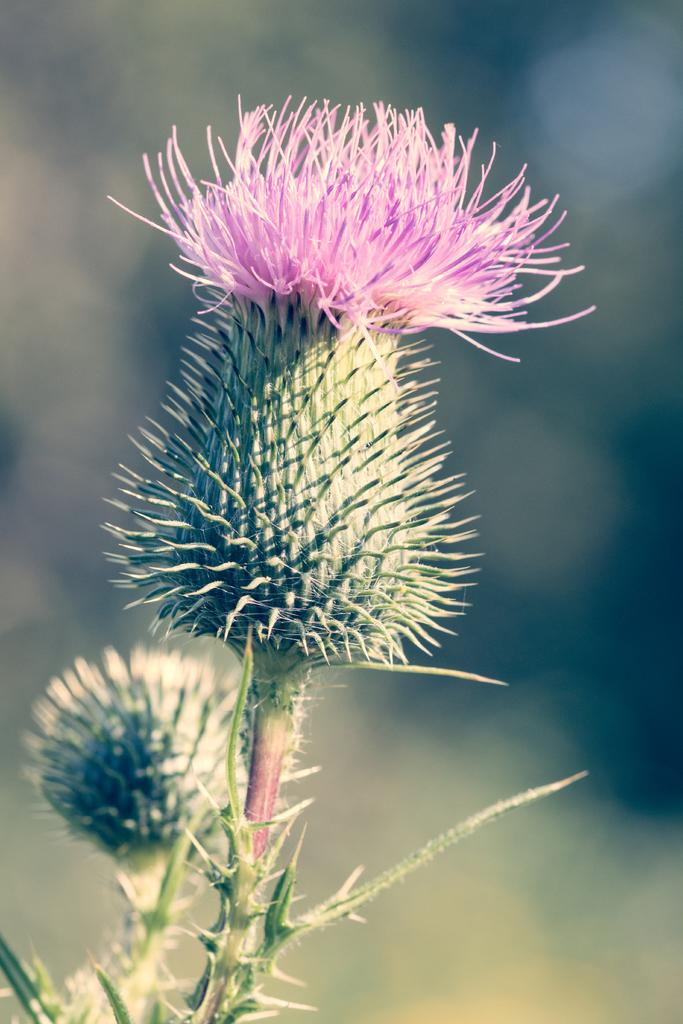Where was the image taken? The image was taken outdoors. Can you describe the background of the image? The background of the image is blurred. What is the main subject of the image? There is a plant in the middle of the image. What are the characteristics of the plant? The plant has stems, thorns, buds, and a flower that is purple in color. What type of advertisement can be seen in the background of the image? There is no advertisement present in the background of the image; it is blurred and only features the plant. How much heat is being emitted by the plant in the image? The image does not provide information about the heat emitted by the plant, as it is focused on the visual characteristics of the plant. 